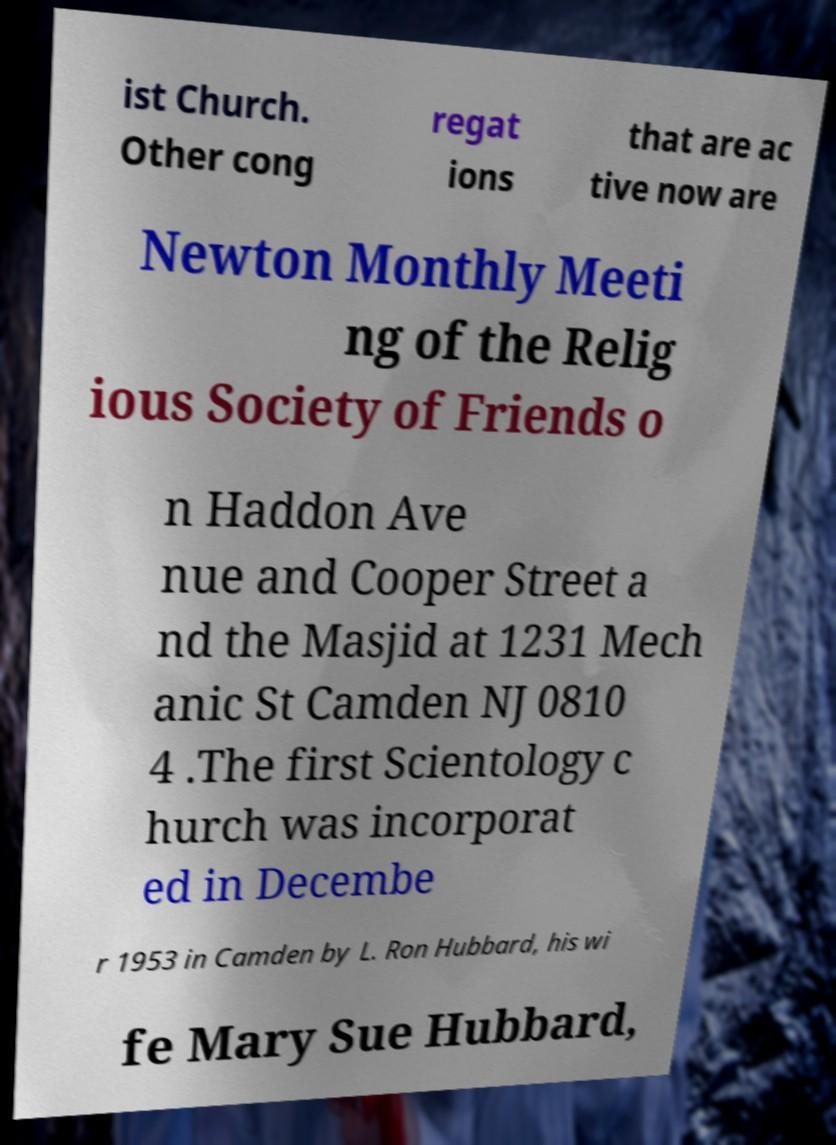For documentation purposes, I need the text within this image transcribed. Could you provide that? ist Church. Other cong regat ions that are ac tive now are Newton Monthly Meeti ng of the Relig ious Society of Friends o n Haddon Ave nue and Cooper Street a nd the Masjid at 1231 Mech anic St Camden NJ 0810 4 .The first Scientology c hurch was incorporat ed in Decembe r 1953 in Camden by L. Ron Hubbard, his wi fe Mary Sue Hubbard, 